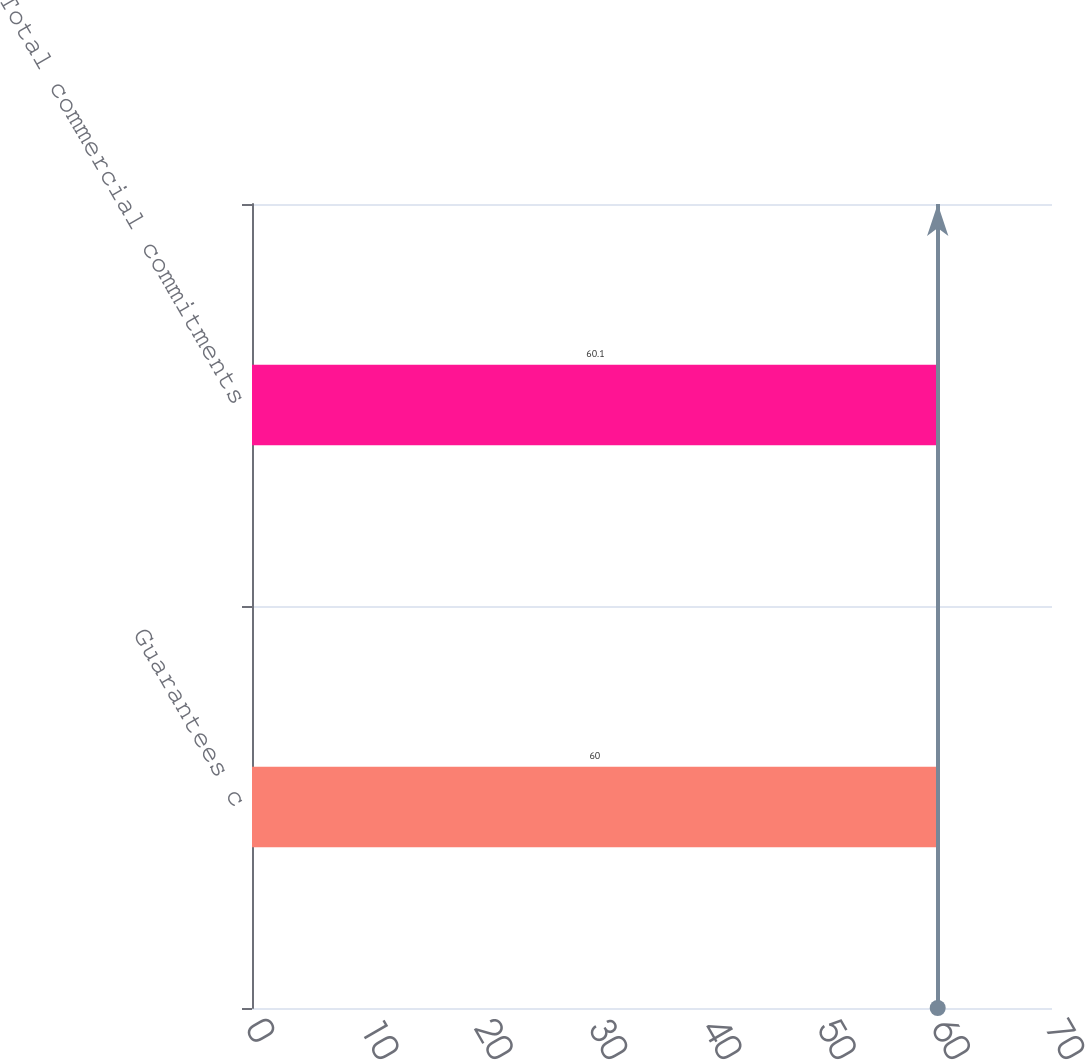Convert chart. <chart><loc_0><loc_0><loc_500><loc_500><bar_chart><fcel>Guarantees c<fcel>Total commercial commitments<nl><fcel>60<fcel>60.1<nl></chart> 